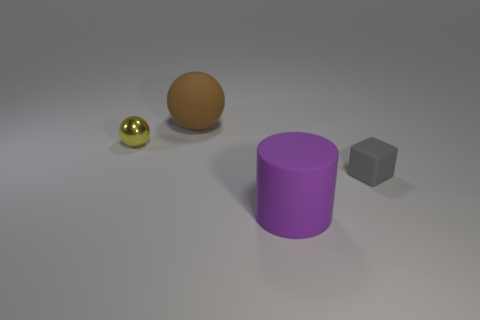Add 2 tiny matte cubes. How many objects exist? 6 Subtract all cylinders. How many objects are left? 3 Add 1 yellow cylinders. How many yellow cylinders exist? 1 Subtract 0 blue balls. How many objects are left? 4 Subtract all tiny blue cubes. Subtract all big purple rubber objects. How many objects are left? 3 Add 3 gray objects. How many gray objects are left? 4 